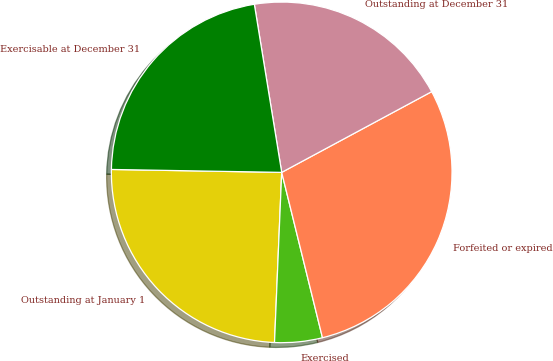Convert chart. <chart><loc_0><loc_0><loc_500><loc_500><pie_chart><fcel>Outstanding at January 1<fcel>Exercised<fcel>Forfeited or expired<fcel>Outstanding at December 31<fcel>Exercisable at December 31<nl><fcel>24.6%<fcel>4.52%<fcel>29.01%<fcel>19.71%<fcel>22.16%<nl></chart> 